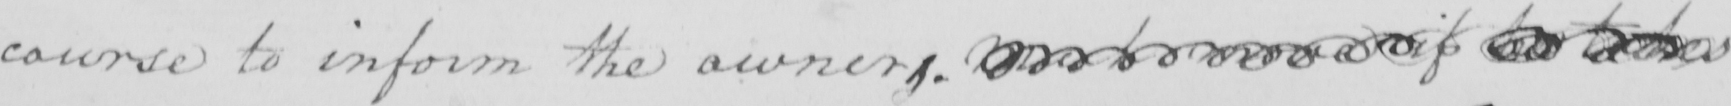Please provide the text content of this handwritten line. course to inform the owners .  <gap/>  to  <gap/>  if  <gap/>  <gap/> 